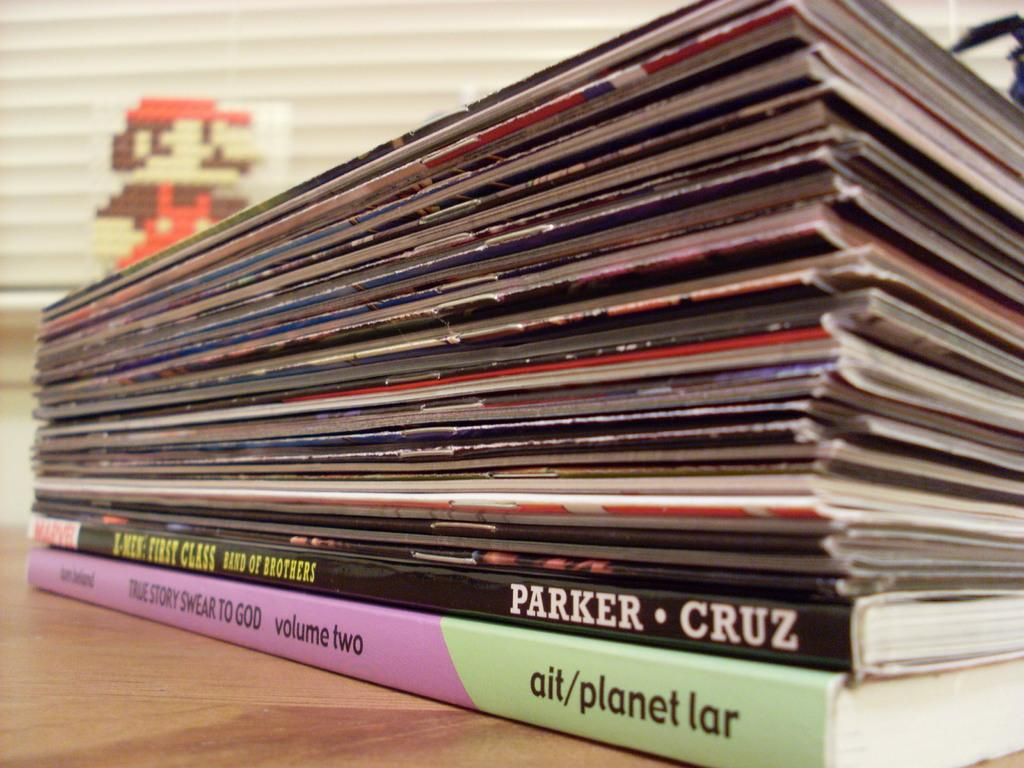<image>
Write a terse but informative summary of the picture. A book by Parker and Cruz sits on top of a book by planet lar 